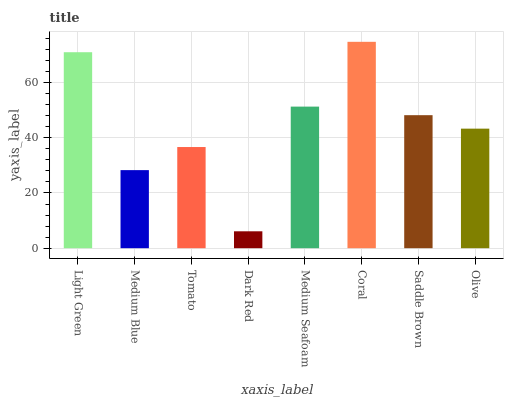Is Dark Red the minimum?
Answer yes or no. Yes. Is Coral the maximum?
Answer yes or no. Yes. Is Medium Blue the minimum?
Answer yes or no. No. Is Medium Blue the maximum?
Answer yes or no. No. Is Light Green greater than Medium Blue?
Answer yes or no. Yes. Is Medium Blue less than Light Green?
Answer yes or no. Yes. Is Medium Blue greater than Light Green?
Answer yes or no. No. Is Light Green less than Medium Blue?
Answer yes or no. No. Is Saddle Brown the high median?
Answer yes or no. Yes. Is Olive the low median?
Answer yes or no. Yes. Is Dark Red the high median?
Answer yes or no. No. Is Saddle Brown the low median?
Answer yes or no. No. 